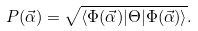<formula> <loc_0><loc_0><loc_500><loc_500>P ( \vec { \alpha } ) = \sqrt { \langle \Phi ( \vec { \alpha } ) | \Theta | \Phi ( \vec { \alpha } ) \rangle } .</formula> 